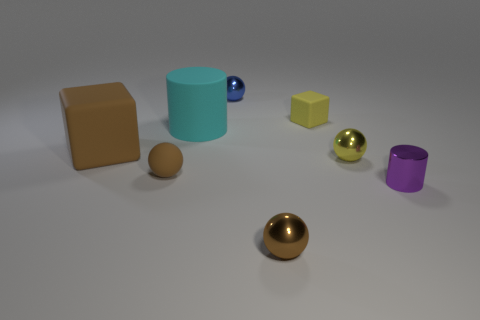Add 1 tiny yellow matte blocks. How many objects exist? 9 Subtract all cubes. How many objects are left? 6 Add 8 small purple cylinders. How many small purple cylinders are left? 9 Add 3 balls. How many balls exist? 7 Subtract 0 blue cylinders. How many objects are left? 8 Subtract all tiny green cylinders. Subtract all yellow matte blocks. How many objects are left? 7 